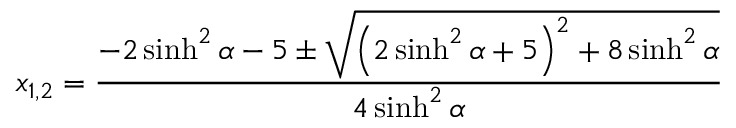Convert formula to latex. <formula><loc_0><loc_0><loc_500><loc_500>x _ { 1 , 2 } = \frac { - 2 \sinh ^ { 2 } \alpha - 5 \pm \sqrt { \left ( 2 \sinh ^ { 2 } { \alpha } + 5 \right ) ^ { 2 } + 8 \sinh ^ { 2 } { \alpha } } } { 4 \sinh ^ { 2 } { \alpha } }</formula> 